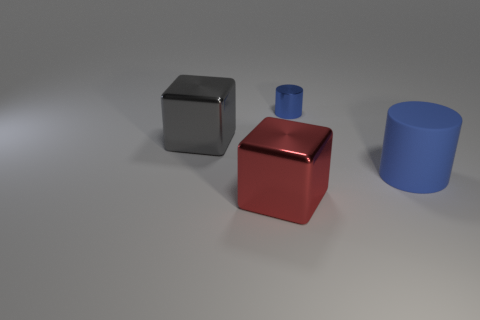There is a object that is the same color as the large cylinder; what material is it?
Your answer should be compact. Metal. What is the shape of the big metal thing that is to the right of the block that is behind the large cylinder?
Keep it short and to the point. Cube. There is a gray thing; are there any big objects in front of it?
Offer a very short reply. Yes. There is a matte cylinder that is the same size as the red metal object; what is its color?
Offer a very short reply. Blue. What number of gray blocks are made of the same material as the red cube?
Offer a very short reply. 1. How many other objects are there of the same size as the shiny cylinder?
Keep it short and to the point. 0. Is there another thing that has the same size as the rubber thing?
Offer a very short reply. Yes. Do the cylinder left of the big blue rubber thing and the large matte thing have the same color?
Ensure brevity in your answer.  Yes. How many things are tiny metallic cylinders or blue objects?
Make the answer very short. 2. There is a thing that is to the right of the blue metal cylinder; does it have the same size as the metallic cylinder?
Your response must be concise. No. 